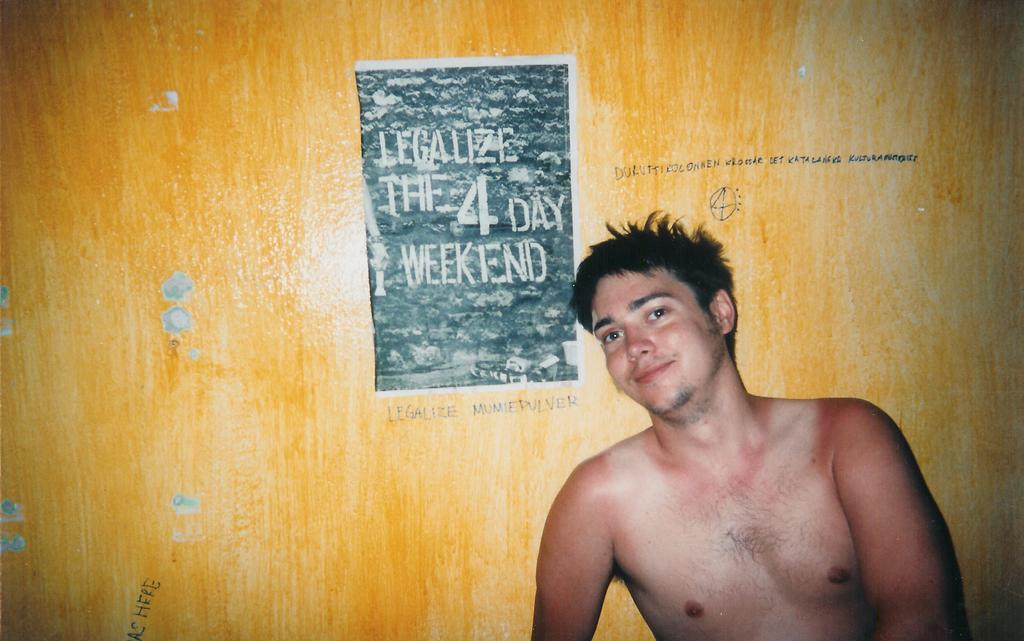Who or what is present in the image? There is a person in the image. What can be seen in the background of the image? There is a wall in the background of the image. What is written or displayed on the wall? There is text on the wall. How many lizards can be seen crawling on the wall in the image? There are no lizards present in the image; only a person, a wall, and text on the wall are visible. 